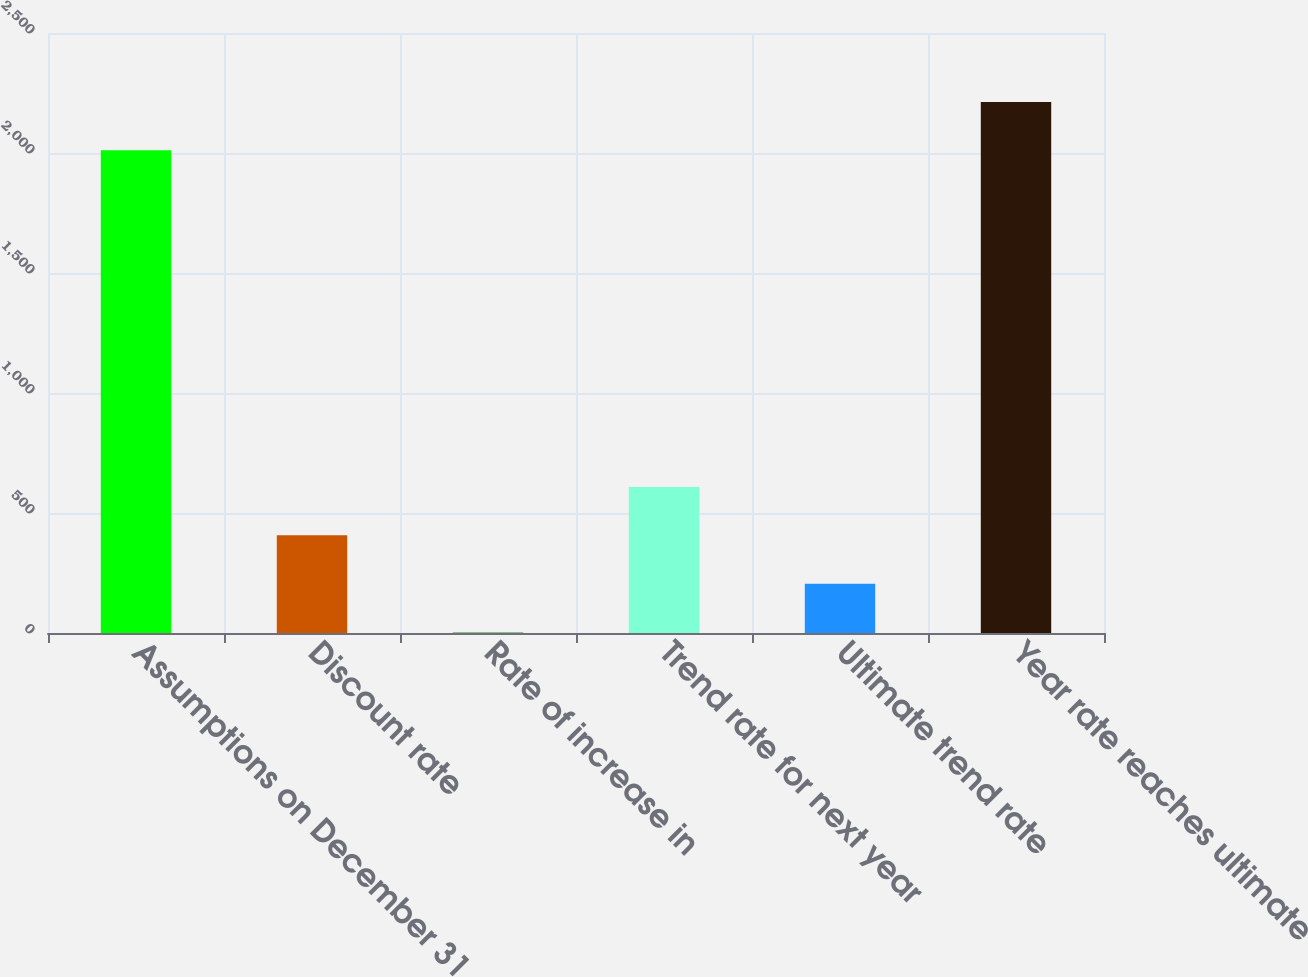Convert chart. <chart><loc_0><loc_0><loc_500><loc_500><bar_chart><fcel>Assumptions on December 31<fcel>Discount rate<fcel>Rate of increase in<fcel>Trend rate for next year<fcel>Ultimate trend rate<fcel>Year rate reaches ultimate<nl><fcel>2011<fcel>406.81<fcel>3.77<fcel>608.33<fcel>205.29<fcel>2212.52<nl></chart> 